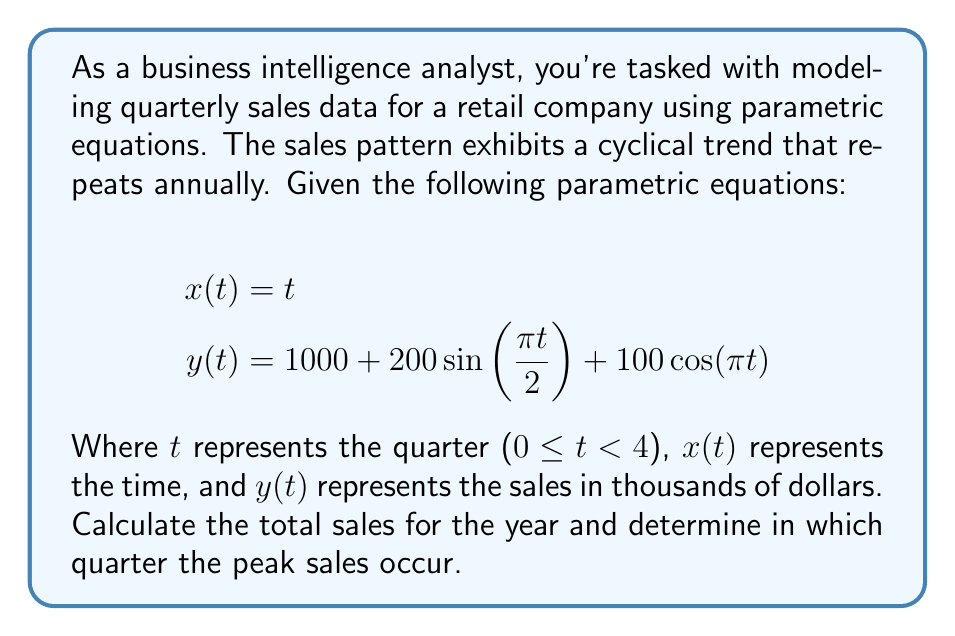What is the answer to this math problem? To solve this problem, we'll follow these steps:

1. Calculate sales for each quarter
2. Sum the quarterly sales to get the total annual sales
3. Identify the quarter with the highest sales

Step 1: Calculate sales for each quarter

We'll evaluate y(t) for t = 0, 1, 2, and 3:

For t = 0 (Q1):
$$y(0) = 1000 + 200\sin(0) + 100\cos(0) = 1000 + 0 + 100 = 1100$$

For t = 1 (Q2):
$$y(1) = 1000 + 200\sin(\frac{\pi}{2}) + 100\cos(\pi) = 1000 + 200 - 100 = 1100$$

For t = 2 (Q3):
$$y(2) = 1000 + 200\sin(\pi) + 100\cos(2\pi) = 1000 + 0 + 100 = 1100$$

For t = 3 (Q4):
$$y(3) = 1000 + 200\sin(\frac{3\pi}{2}) + 100\cos(3\pi) = 1000 - 200 - 100 = 700$$

Step 2: Sum the quarterly sales

Total annual sales = 1100 + 1100 + 1100 + 700 = 4000 thousand dollars or $4 million

Step 3: Identify the quarter with the highest sales

Q1, Q2, and Q3 all have the same peak sales of $1.1 million, while Q4 has the lowest sales of $0.7 million.
Answer: The total sales for the year are $4 million. The peak sales occur in Q1, Q2, and Q3, each with sales of $1.1 million. 